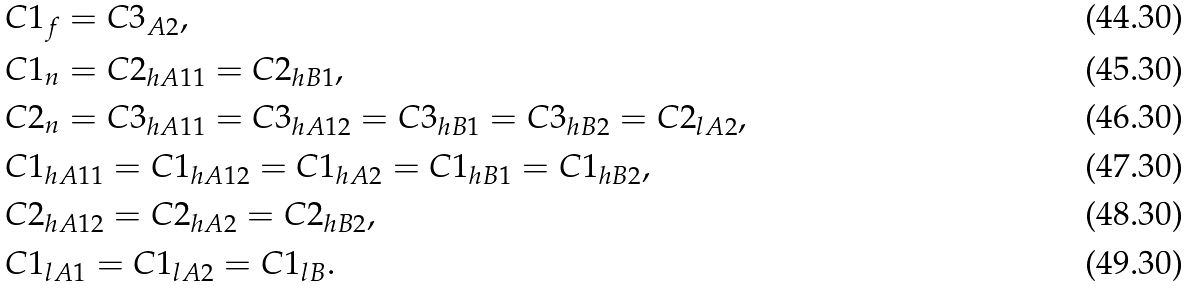<formula> <loc_0><loc_0><loc_500><loc_500>& C 1 _ { f } = C 3 _ { A 2 } , \\ & C 1 _ { n } = C 2 _ { h A 1 1 } = C 2 _ { h B 1 } , \\ & C 2 _ { n } = C 3 _ { h A 1 1 } = C 3 _ { h A 1 2 } = C 3 _ { h B 1 } = C 3 _ { h B 2 } = C 2 _ { l A 2 } , \\ & C 1 _ { h A 1 1 } = C 1 _ { h A 1 2 } = C 1 _ { h A 2 } = C 1 _ { h B 1 } = C 1 _ { h B 2 } , \\ & C 2 _ { h A 1 2 } = C 2 _ { h A 2 } = C 2 _ { h B 2 } , \\ & C 1 _ { l A 1 } = C 1 _ { l A 2 } = C 1 _ { l B } .</formula> 